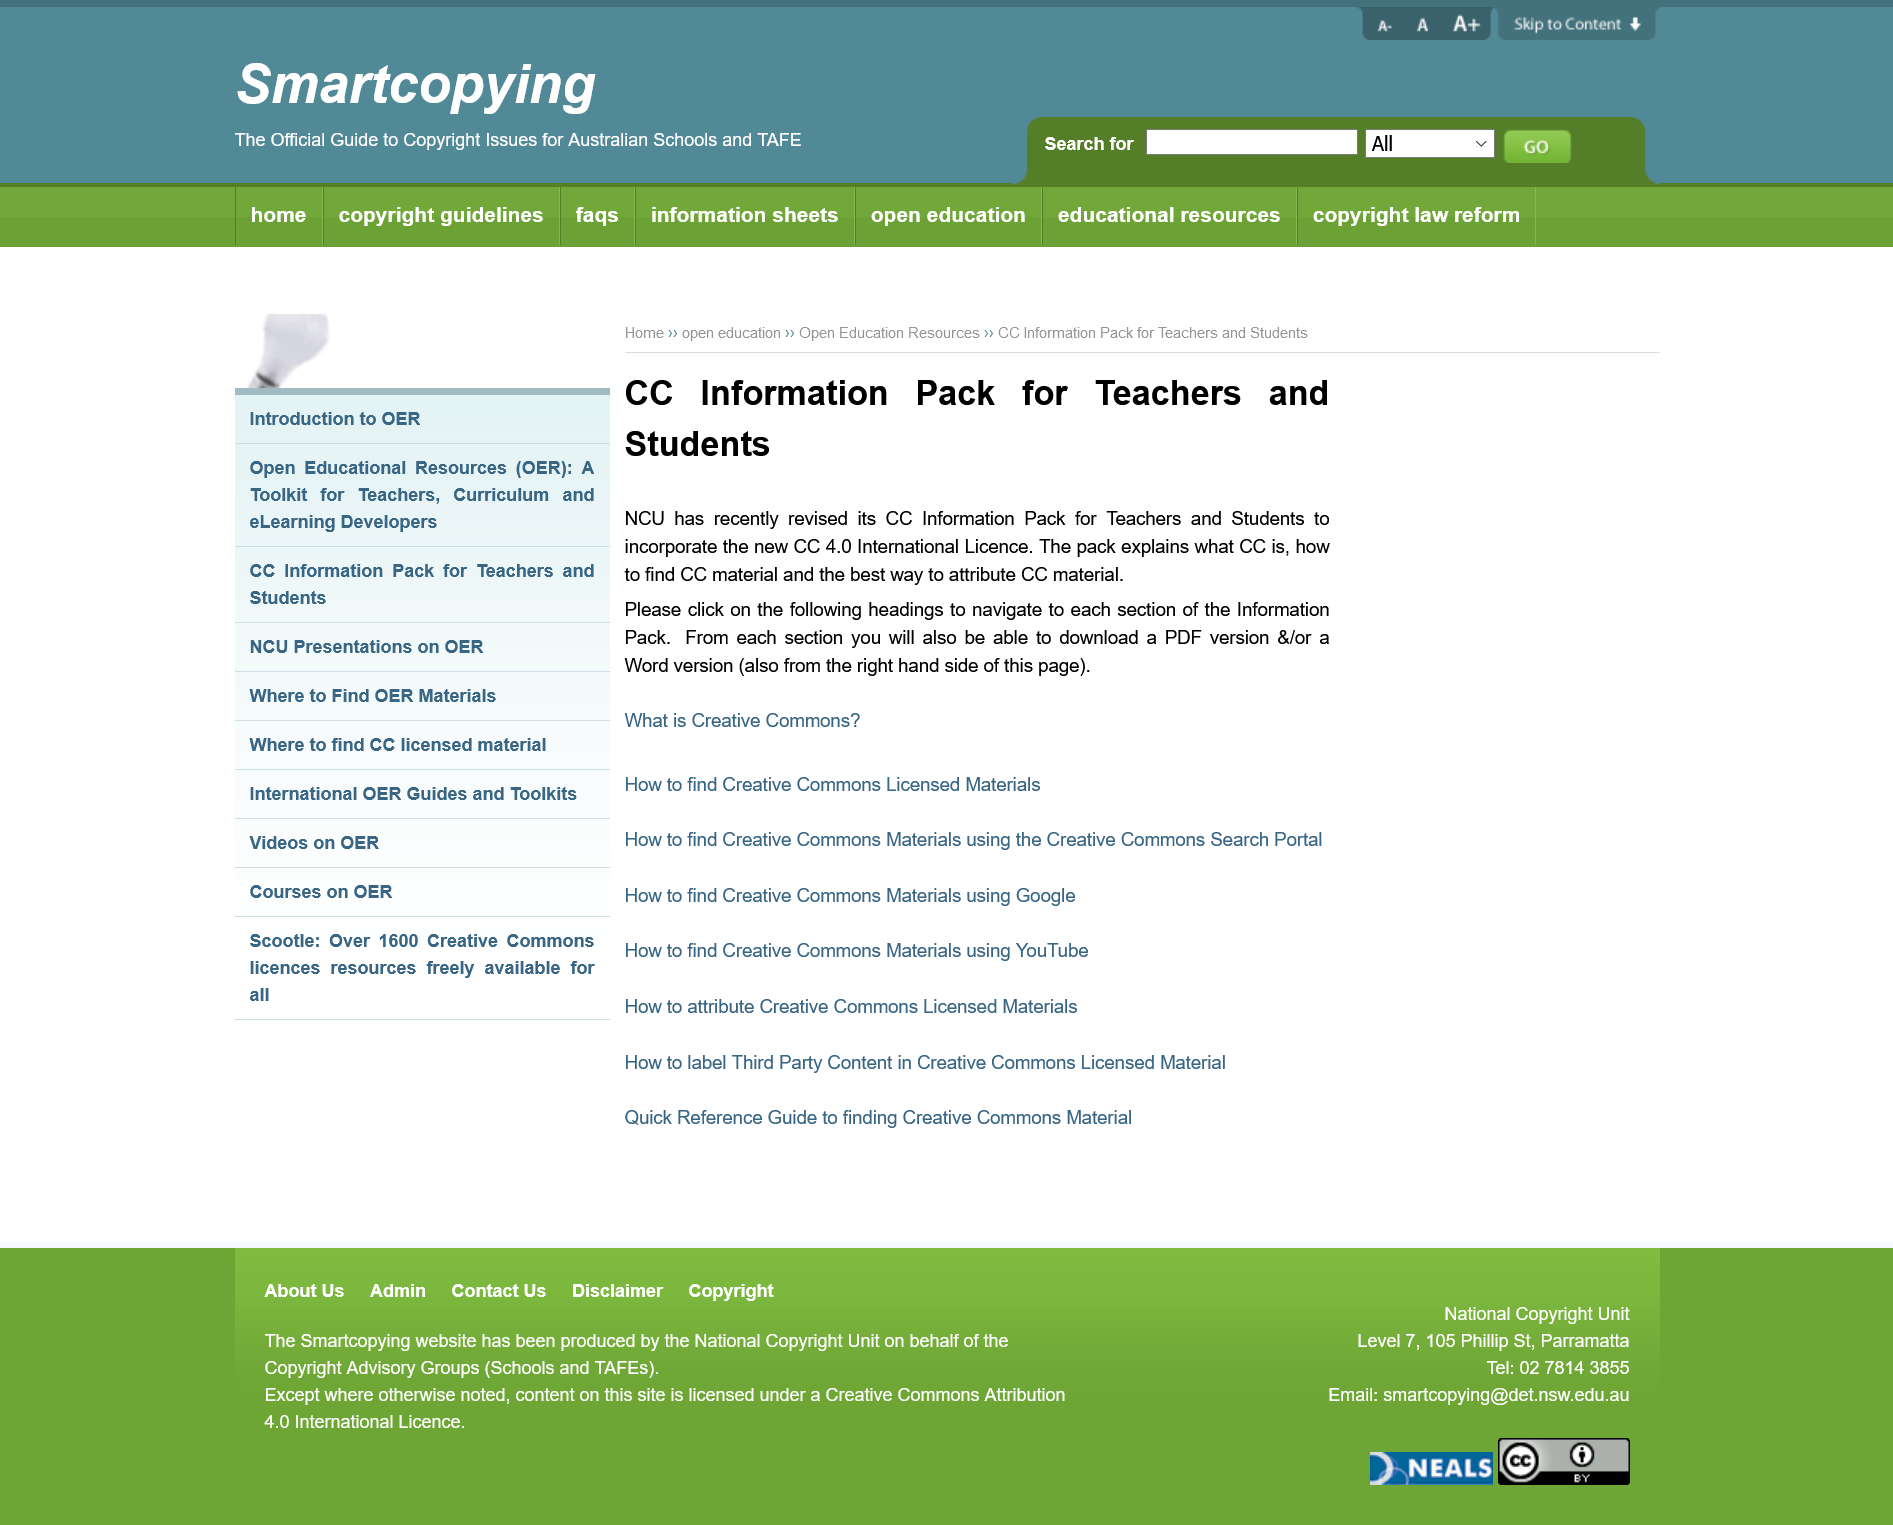Give some essential details in this illustration. The information packs are available for download in both PDF and Word formats. Creative Commons Information Packs are available for download by teachers and students. The information packs can be downloaded in PDF or Word format on the right-hand side of the page, specifically in the location designated for such materials. 